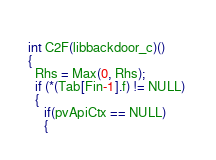Convert code to text. <code><loc_0><loc_0><loc_500><loc_500><_C_> 
int C2F(libbackdoor_c)()
{
  Rhs = Max(0, Rhs);
  if (*(Tab[Fin-1].f) != NULL) 
  {
     if(pvApiCtx == NULL)
     {</code> 